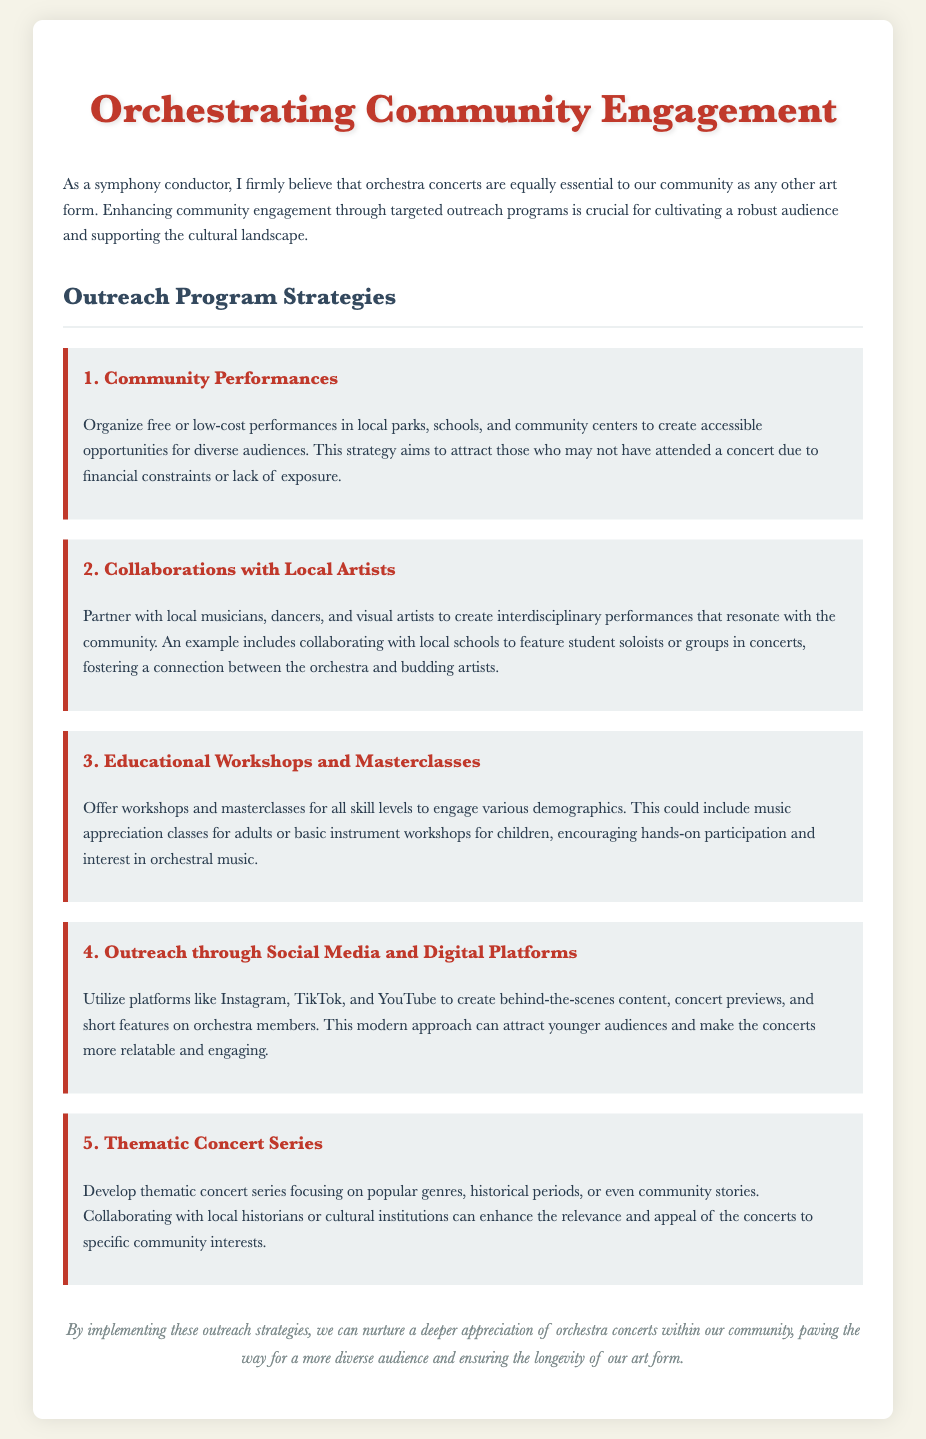What is the title of the document? The title is indicated in the HTML title tag.
Answer: Orchestra Outreach Strategies What is the first outreach strategy mentioned? It is mentioned as a heading in the strategies section of the document.
Answer: Community Performances What is the goal of community performances? The goal is stated in the description accompanying the first strategy.
Answer: Create accessible opportunities How many strategies for outreach programs are listed? The number of strategies is determined by counting the sections under the outreach strategies header.
Answer: Five Which social media platforms are suggested for outreach? The platforms are listed in the description of the fourth strategy.
Answer: Instagram, TikTok, YouTube What type of events are suggested for local collaborations? The suggested events are found in the second outreach strategy.
Answer: Interdisciplinary performances What is the intended audience for educational workshops? The intended audience is mentioned in the description of the third strategy.
Answer: All skill levels What is the theme of the concert series proposed? The theme is suggested in the fifth strategy.
Answer: Popular genres, historical periods, community stories How does the document describe the impact of outreach strategies? The impact is summarized in the concluding paragraph.
Answer: Nurture a deeper appreciation 